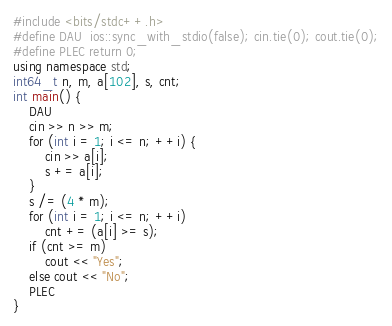Convert code to text. <code><loc_0><loc_0><loc_500><loc_500><_C++_>#include <bits/stdc++.h>
#define DAU  ios::sync_with_stdio(false); cin.tie(0); cout.tie(0);
#define PLEC return 0;
using namespace std;
int64_t n, m, a[102], s, cnt;
int main() {
    DAU
    cin >> n >> m;
    for (int i = 1; i <= n; ++i) {
        cin >> a[i];
        s += a[i];
    }
    s /= (4 * m);
    for (int i = 1; i <= n; ++i)
        cnt += (a[i] >= s);
    if (cnt >= m)
        cout << "Yes";
    else cout << "No";
    PLEC
}
</code> 